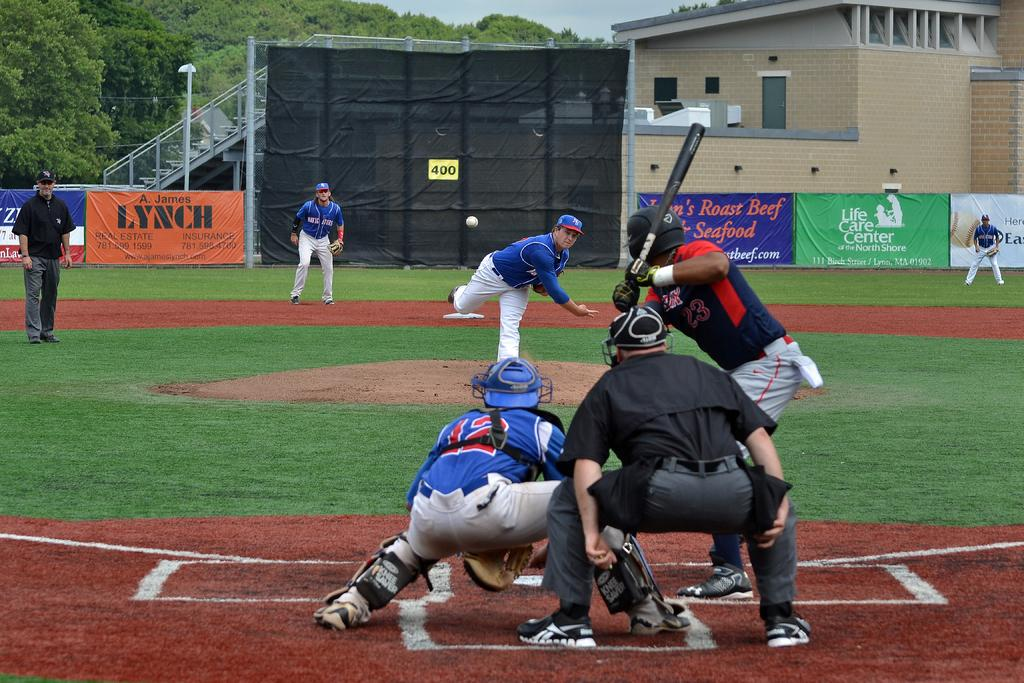<image>
Share a concise interpretation of the image provided. A baseball player wearing the number 23 watches a pitch and prepares to swing. 